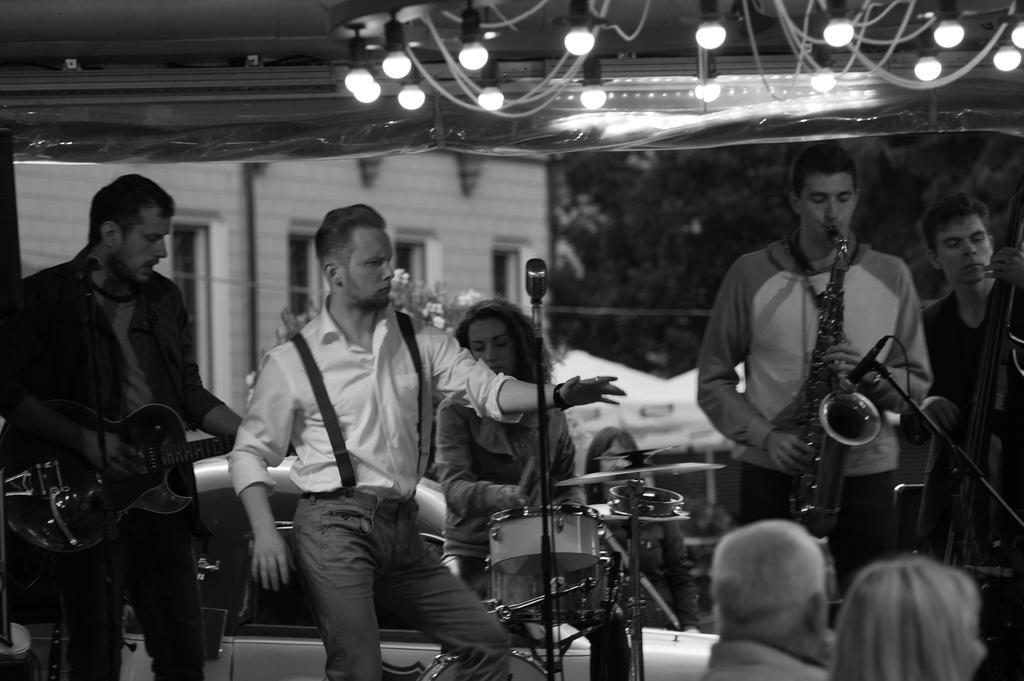Please provide a concise description of this image. In this image there are group of persons who are playing musical instruments. 